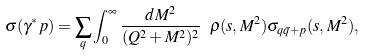<formula> <loc_0><loc_0><loc_500><loc_500>\sigma ( \gamma ^ { * } p ) = \sum _ { q } \int ^ { \infty } _ { 0 } \frac { d M ^ { 2 } } { ( Q ^ { 2 } + M ^ { 2 } ) ^ { 2 } } \ \rho ( s , M ^ { 2 } ) \sigma _ { q \bar { q } + p } ( s , M ^ { 2 } ) ,</formula> 